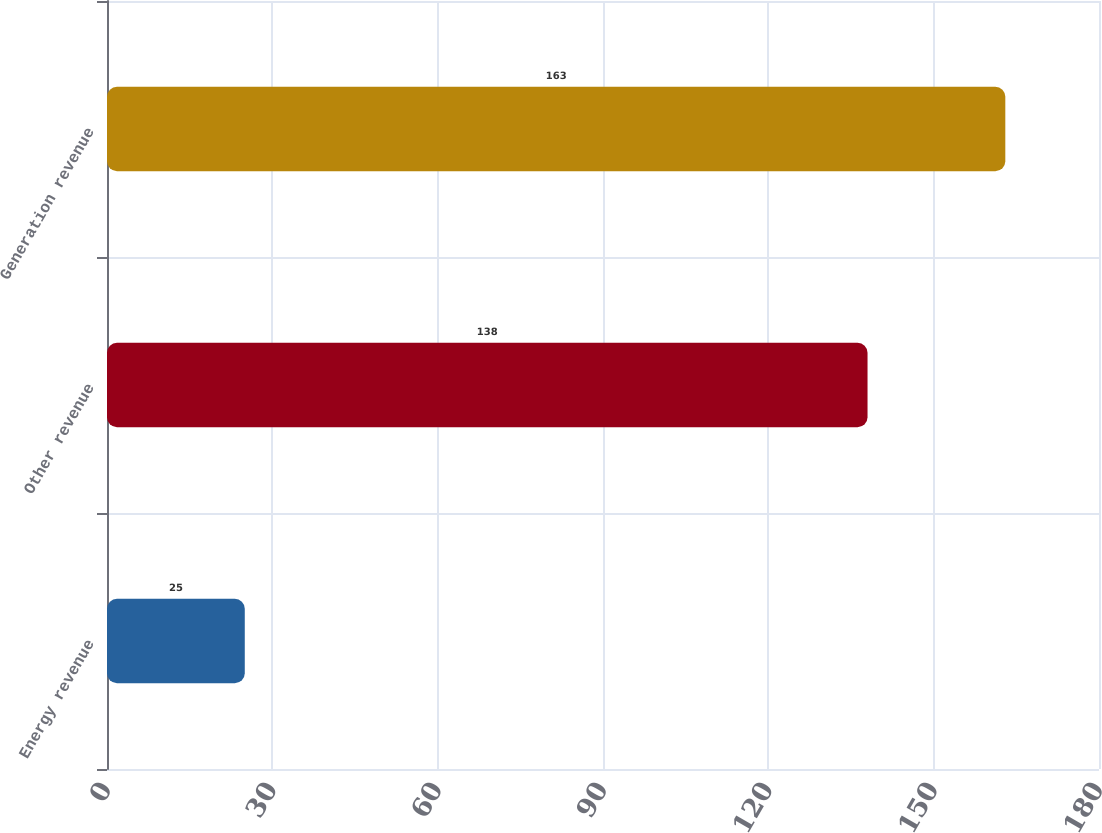Convert chart to OTSL. <chart><loc_0><loc_0><loc_500><loc_500><bar_chart><fcel>Energy revenue<fcel>Other revenue<fcel>Generation revenue<nl><fcel>25<fcel>138<fcel>163<nl></chart> 